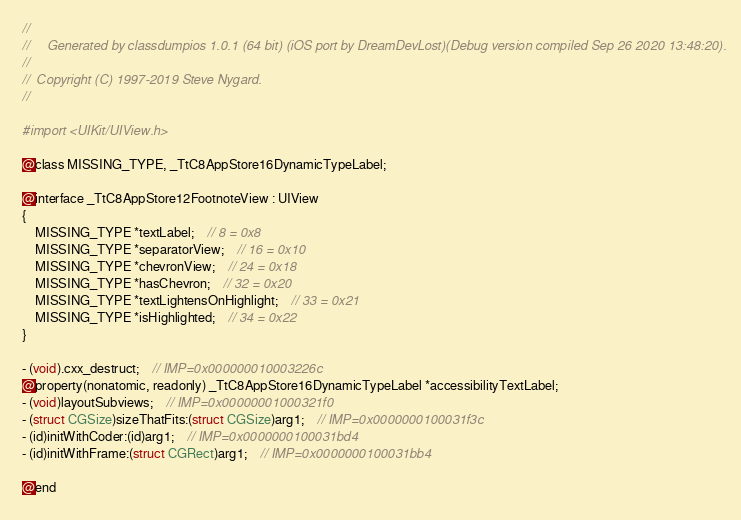Convert code to text. <code><loc_0><loc_0><loc_500><loc_500><_C_>//
//     Generated by classdumpios 1.0.1 (64 bit) (iOS port by DreamDevLost)(Debug version compiled Sep 26 2020 13:48:20).
//
//  Copyright (C) 1997-2019 Steve Nygard.
//

#import <UIKit/UIView.h>

@class MISSING_TYPE, _TtC8AppStore16DynamicTypeLabel;

@interface _TtC8AppStore12FootnoteView : UIView
{
    MISSING_TYPE *textLabel;	// 8 = 0x8
    MISSING_TYPE *separatorView;	// 16 = 0x10
    MISSING_TYPE *chevronView;	// 24 = 0x18
    MISSING_TYPE *hasChevron;	// 32 = 0x20
    MISSING_TYPE *textLightensOnHighlight;	// 33 = 0x21
    MISSING_TYPE *isHighlighted;	// 34 = 0x22
}

- (void).cxx_destruct;	// IMP=0x000000010003226c
@property(nonatomic, readonly) _TtC8AppStore16DynamicTypeLabel *accessibilityTextLabel;
- (void)layoutSubviews;	// IMP=0x00000001000321f0
- (struct CGSize)sizeThatFits:(struct CGSize)arg1;	// IMP=0x0000000100031f3c
- (id)initWithCoder:(id)arg1;	// IMP=0x0000000100031bd4
- (id)initWithFrame:(struct CGRect)arg1;	// IMP=0x0000000100031bb4

@end

</code> 